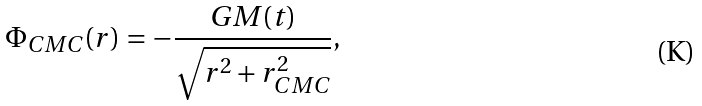Convert formula to latex. <formula><loc_0><loc_0><loc_500><loc_500>\Phi _ { C M C } ( r ) = - \frac { G M ( t ) } { \sqrt { r ^ { 2 } + r _ { C M C } ^ { 2 } } } ,</formula> 